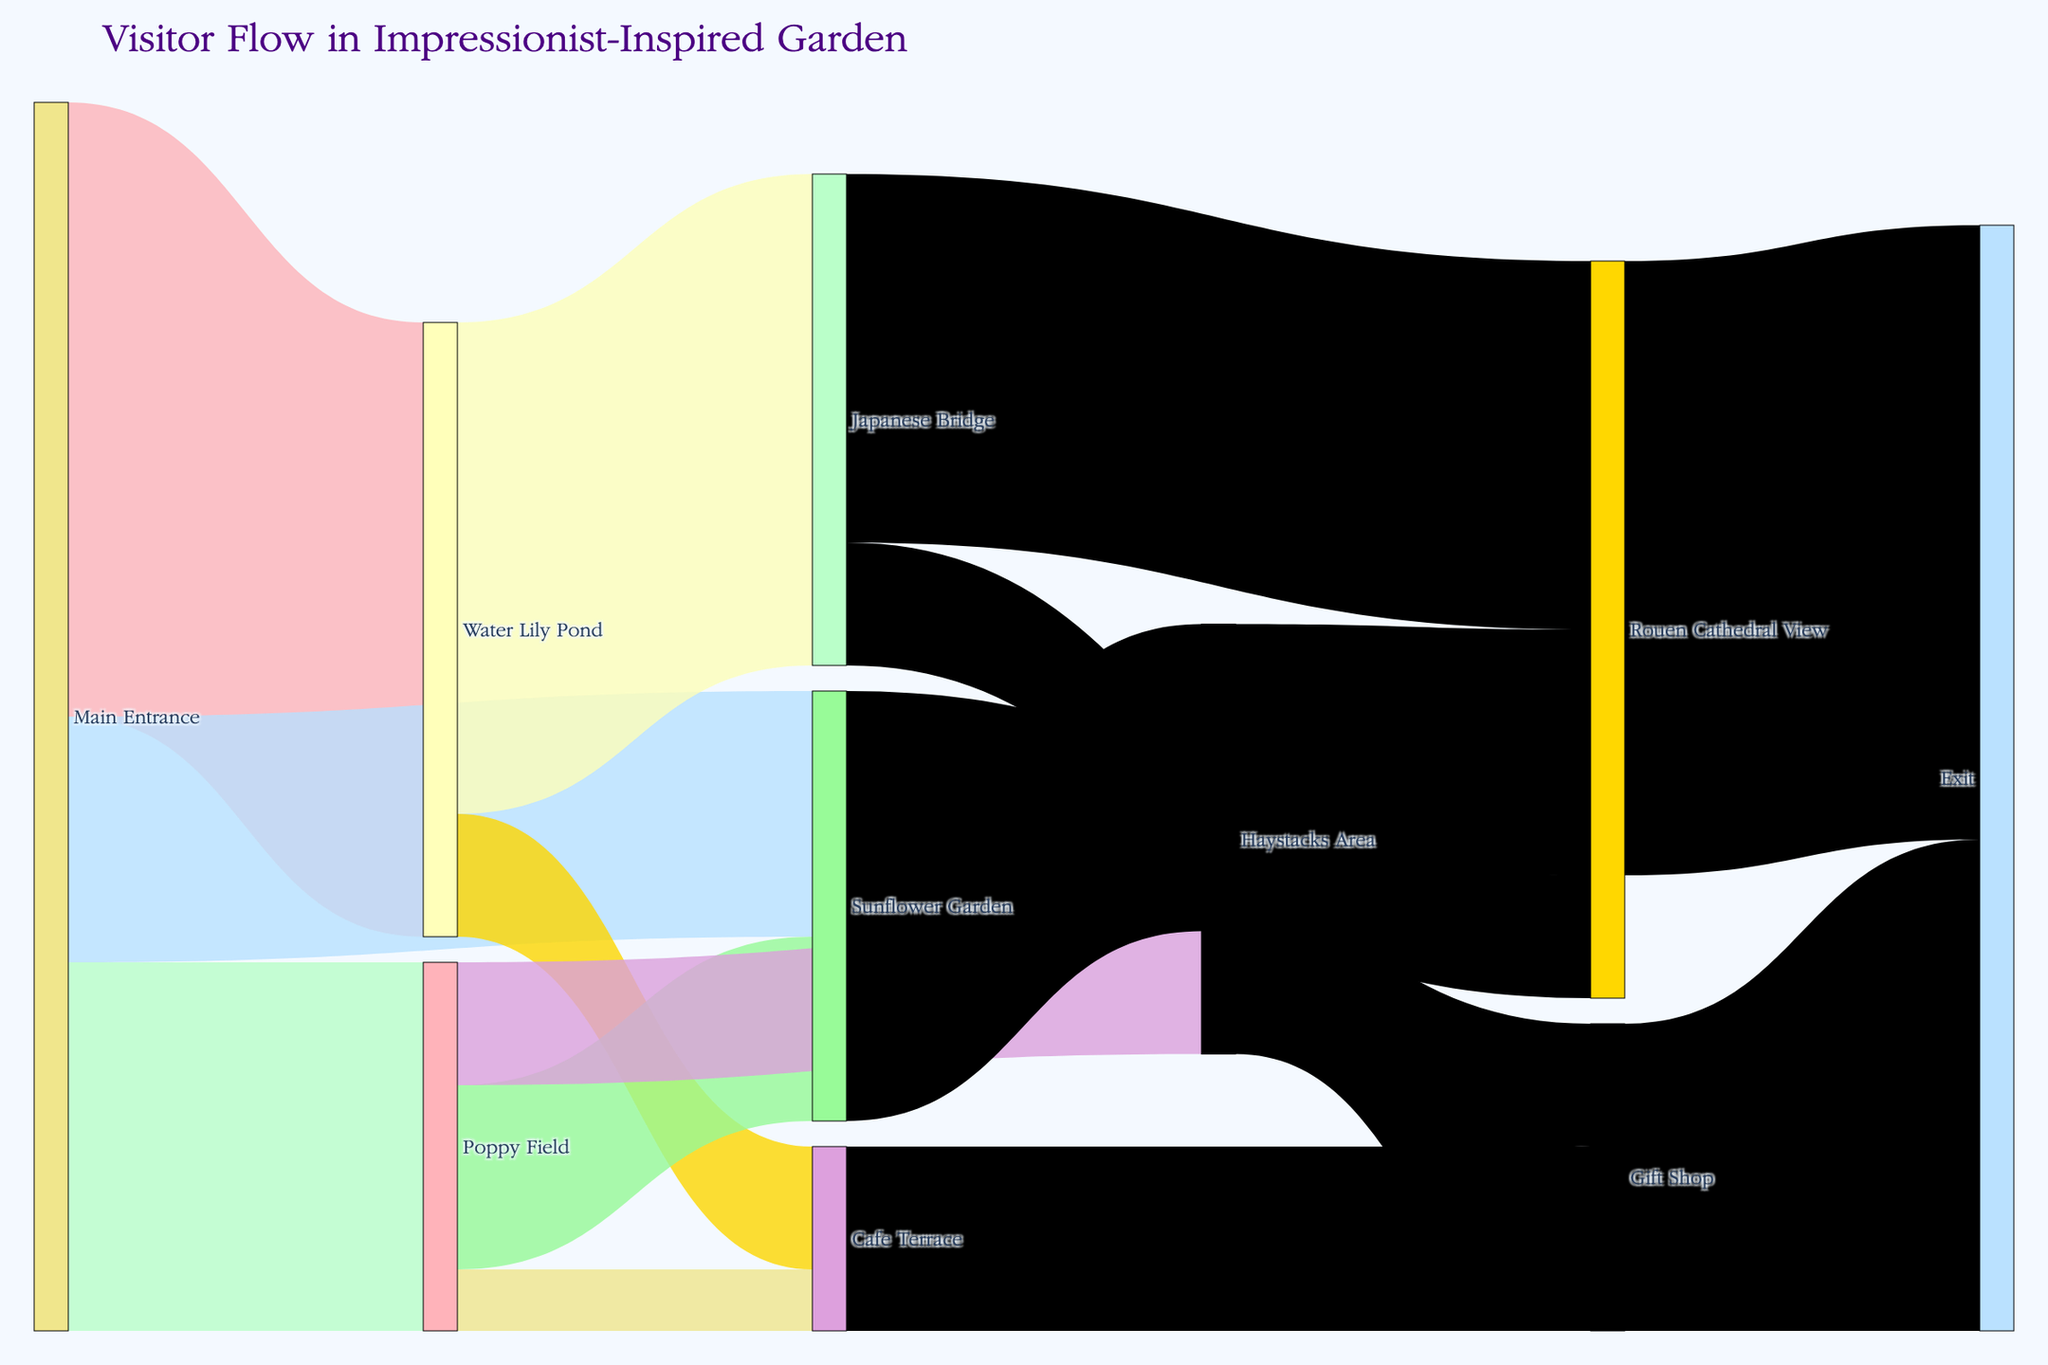What is the title of the Sankey Diagram? The title can be found at the top of the diagram, which is often used to describe the focus or the main takeaway of the visual representation.
Answer: Visitor Flow in Impressionist-Inspired Garden How many visitors entered the garden through the Main Entrance? To find out the total number of visitors entering through the Main Entrance, sum up the values of all the flows originating from this node: 500 (Water Lily Pond) + 300 (Poppy Field) + 200 (Sunflower Garden).
Answer: 1000 Which area receives the highest number of visitors directly from the Main Entrance? Look at the values of the flows coming out from the Main Entrance and compare them. The highest value represents the most popular immediate destination.
Answer: Water Lily Pond How many visitors eventually exit through the Exit node? Sum up the values of all flows ending at the Exit node: 500 (from Rouen Cathedral View) + 150 (from Cafe Terrace) + 250 (from Gift Shop).
Answer: 900 Which path has the highest drop-off from the Main Entrance? Compare the value differences of the visitors moving from the Main Entrance to subsequent nodes by examining the value flows directly from Main Entrance. The largest difference will indicate the highest drop-off.
Answer: Sunflower Garden What is the total number of visitors passing through the Gift Shop? Visitors going to the Gift Shop come from Japanese Bridge (100) and from the Haystacks Area (150). Sum these numbers: 100 + 150.
Answer: 250 How many visitors travel from the Water Lily Pond to the Japanese Bridge? Check the flow value connecting the Water Lily Pond and the Japanese Bridge.
Answer: 400 Which area has more visitors: Cafe Terrace or Rouen Cathedral View? Compare the flow values ending at each respective node. Sum incoming flows if they come from different nodes, e.g., Rouen Cathedral View: 100 (Sunflower Garden) + 300 (Japanese Bridge) + 200 (Haystacks Area); Cafe Terrace: 100 (Water Lily Pond) + 50 (Poppy Field).
Answer: Rouen Cathedral View Which pathway from the Main Entrance has the lowest number of visitors? Compare the flow values of all the paths originating from the Main Entrance: 500 (Water Lily Pond), 300 (Poppy Field), and 200 (Sunflower Garden). The path with the smallest value is the answer.
Answer: Sunflower Garden How many visitors move from Haystacks Area to Rouen Cathedral View compared to those moving to the Gift Shop? Compare the respective flow values from Haystacks Area to Rouen Cathedral View (200) and to the Gift Shop (150).
Answer: More visitors to Rouen Cathedral View 